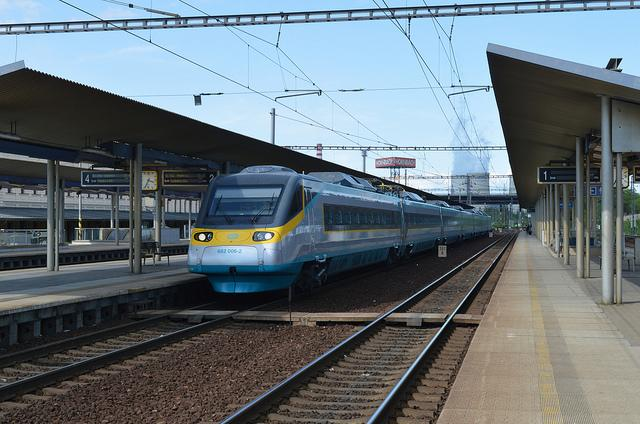What is the item closest to the green sign on the left that has the number 4 on it? clock 